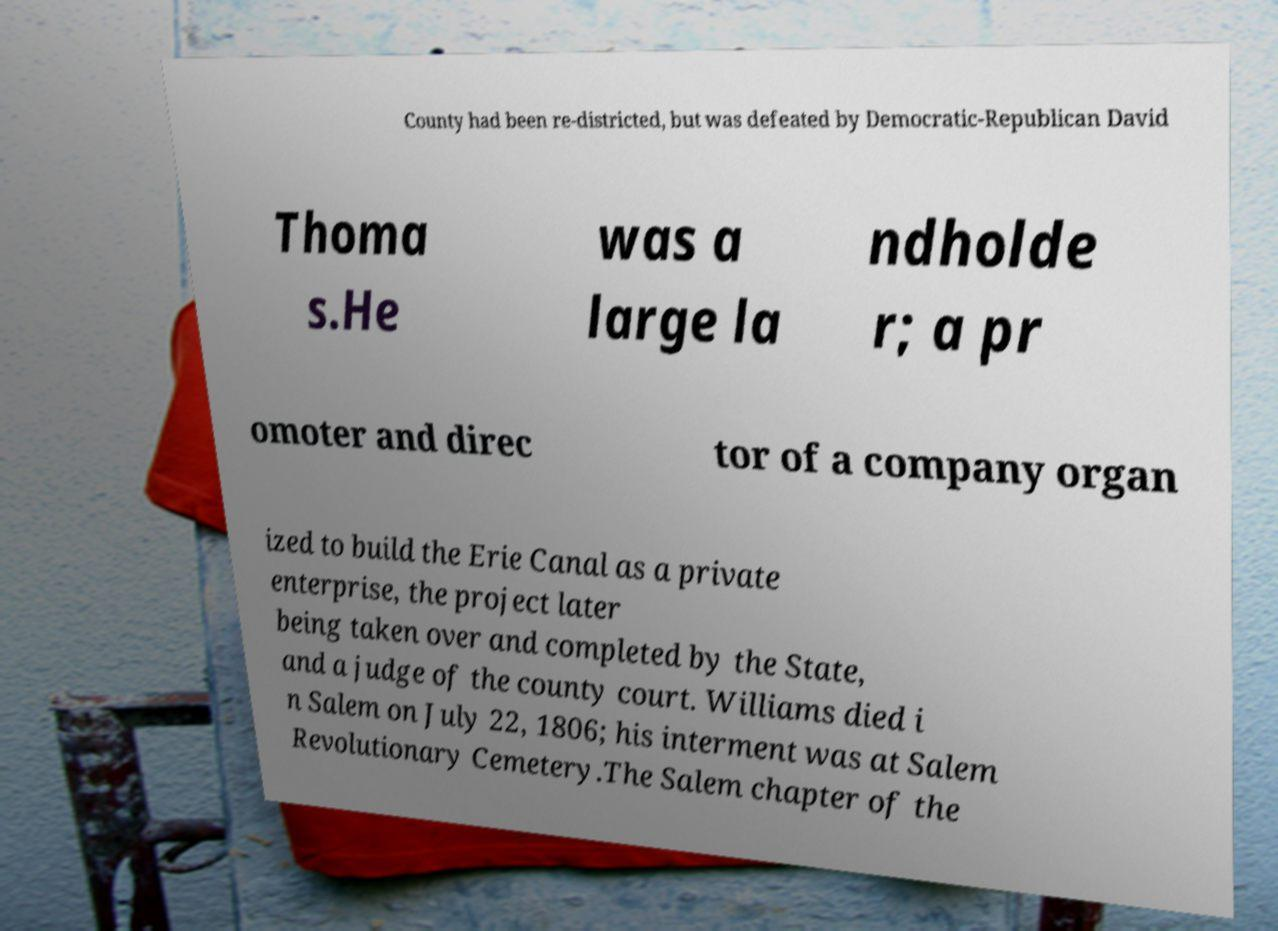There's text embedded in this image that I need extracted. Can you transcribe it verbatim? County had been re-districted, but was defeated by Democratic-Republican David Thoma s.He was a large la ndholde r; a pr omoter and direc tor of a company organ ized to build the Erie Canal as a private enterprise, the project later being taken over and completed by the State, and a judge of the county court. Williams died i n Salem on July 22, 1806; his interment was at Salem Revolutionary Cemetery.The Salem chapter of the 